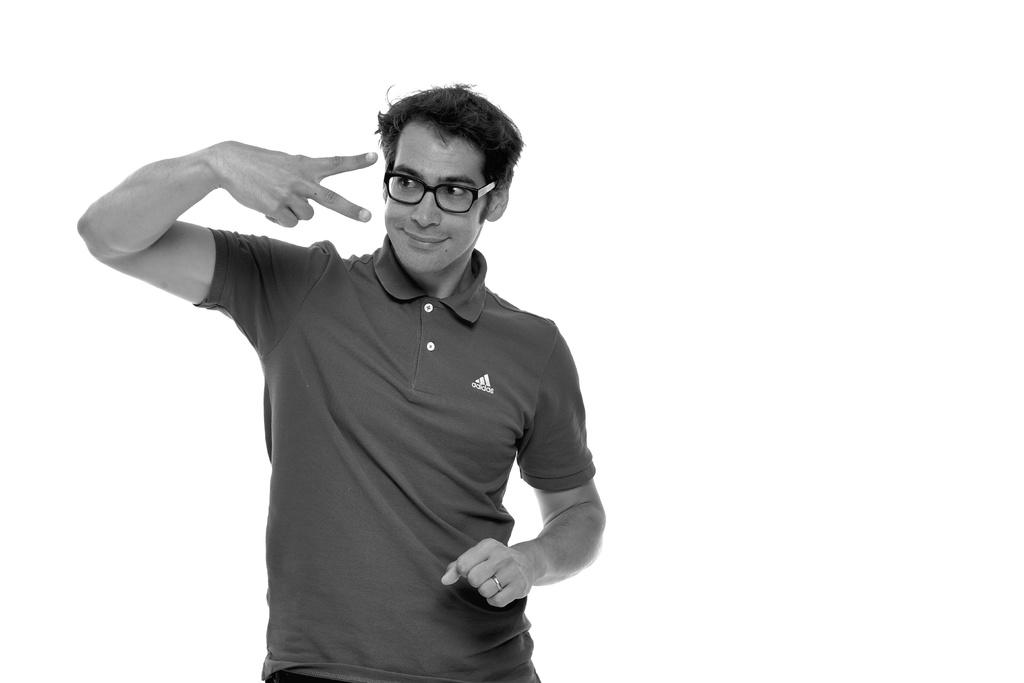What is the color scheme of the image? The image is black and white. Who is present in the image? There is a man in the image. What is the man doing in the image? The man is standing in the image. What accessory is the man wearing in the image? The man is wearing glasses in the image. What type of plough is the man using in the image? There is no plough present in the image; it features a man standing and wearing glasses. How does the fan help the man in the image? There is no fan present in the image, so it cannot help the man. 